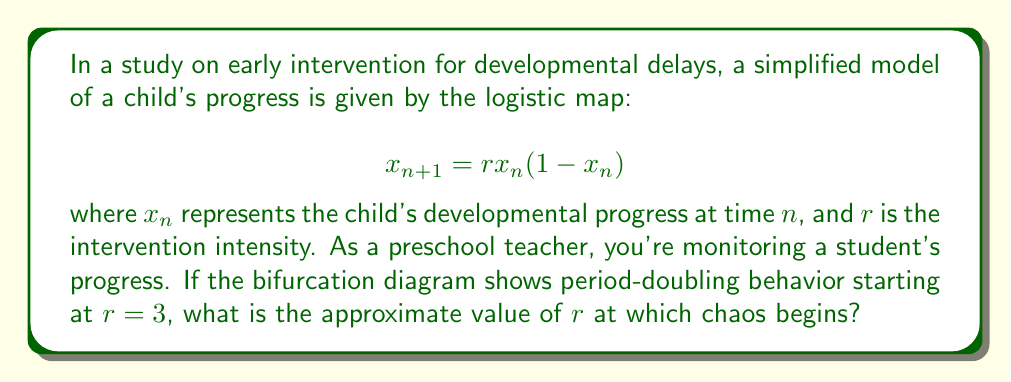Can you solve this math problem? To determine the onset of chaos in the logistic map, we need to understand the period-doubling cascade:

1) The logistic map undergoes period-doubling bifurcations as $r$ increases.
2) These bifurcations occur at increasingly shorter intervals.
3) The ratio between successive bifurcation intervals approaches the Feigenbaum constant: $\delta \approx 4.669201$.

Let's denote the $r$-values at which bifurcations occur as $r_1, r_2, r_3, ...$

Given: $r_1 = 3$ (first period-doubling)

We can estimate subsequent bifurcations:

$$r_{n+1} - r_n \approx \frac{r_n - r_{n-1}}{\delta}$$

After an infinite number of period-doublings, chaos begins. This point is called the accumulation point, $r_\infty$.

We can approximate $r_\infty$ using the geometric series:

$$r_\infty \approx r_1 + (r_2 - r_1) + (r_3 - r_2) + ...$$

$$= r_1 + (r_2 - r_1)(1 + \frac{1}{\delta} + \frac{1}{\delta^2} + ...)$$

$$= r_1 + (r_2 - r_1)(\frac{\delta}{\delta-1})$$

We don't know $r_2$ exactly, but we can estimate it:

$$r_2 \approx r_1 + \frac{r_1 - r_0}{\delta} \approx 3 + \frac{3}{\delta} \approx 3.64$$

Now we can calculate $r_\infty$:

$$r_\infty \approx 3 + (3.64 - 3)(\frac{4.669201}{4.669201-1}) \approx 3.57$$

Therefore, chaos begins at approximately $r = 3.57$.
Answer: $r \approx 3.57$ 